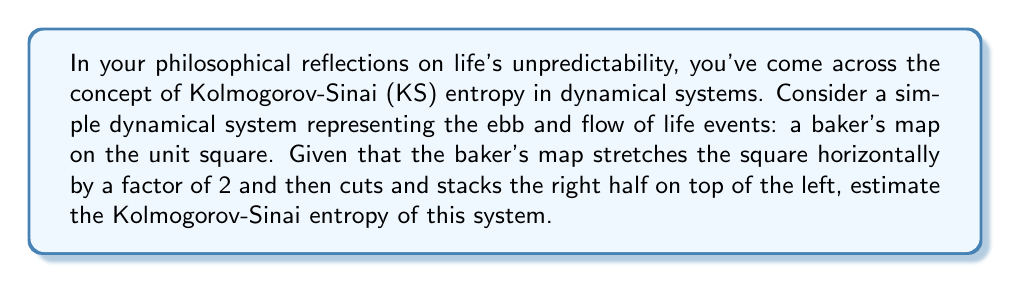Show me your answer to this math problem. To estimate the Kolmogorov-Sinai entropy of the baker's map, we'll follow these steps:

1. Understand the baker's map:
   The baker's map is a chaotic dynamical system that stretches the unit square horizontally by a factor of 2, then cuts it vertically in half, and stacks the right half on top of the left half.

2. Identify the Lyapunov exponents:
   The baker's map has two Lyapunov exponents:
   $\lambda_1 = \ln(2)$ (stretching in the horizontal direction)
   $\lambda_2 = -\ln(2)$ (compression in the vertical direction)

3. Apply Pesin's formula:
   The Kolmogorov-Sinai entropy for a smooth ergodic system is equal to the sum of the positive Lyapunov exponents. In this case:

   $h_{KS} = \sum_{\lambda_i > 0} \lambda_i$

4. Calculate the KS entropy:
   Since only $\lambda_1$ is positive:
   $h_{KS} = \lambda_1 = \ln(2)$

5. Interpret the result:
   The positive KS entropy indicates that the system is chaotic, reflecting the unpredictability in the long-term behavior of trajectories within the system.
Answer: $\ln(2)$ 